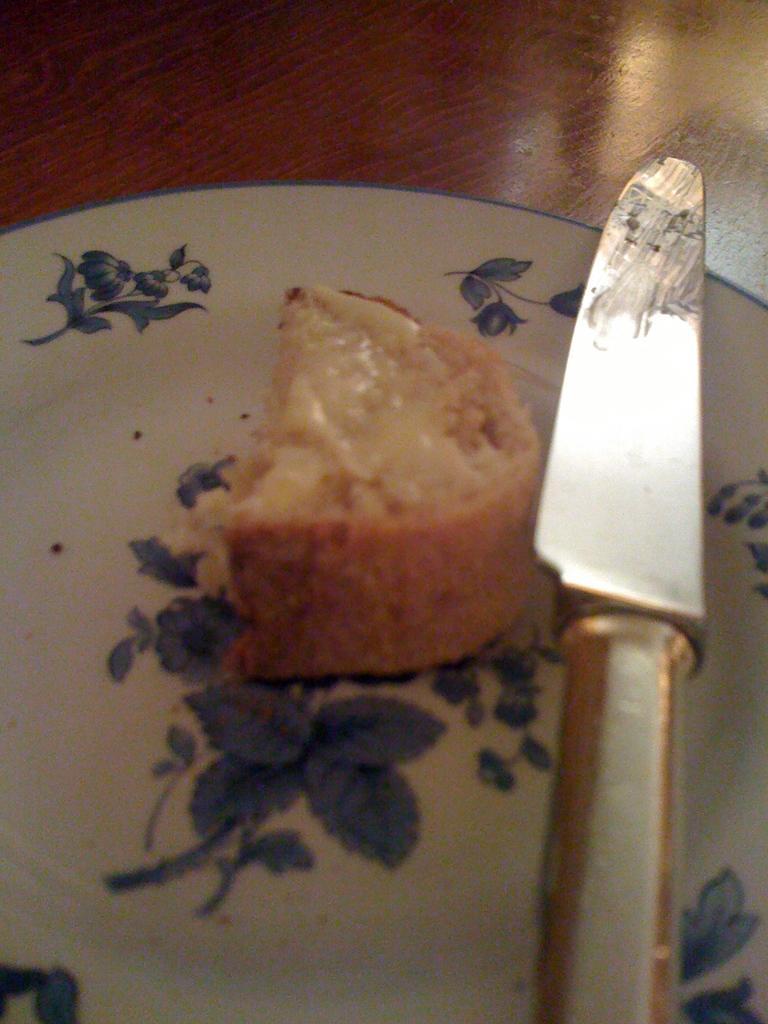Could you give a brief overview of what you see in this image? In this picture, we see a plate containing cake and knife are placed on a brown color table. 